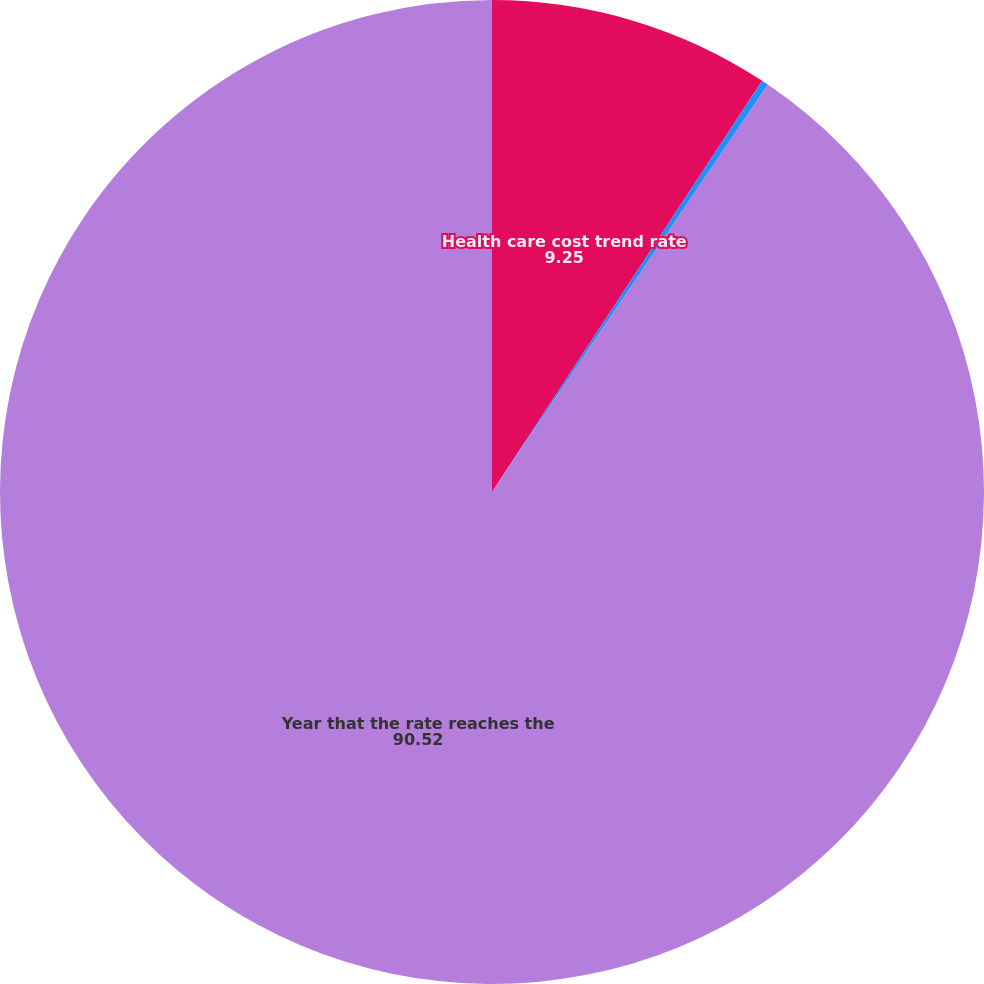Convert chart. <chart><loc_0><loc_0><loc_500><loc_500><pie_chart><fcel>Health care cost trend rate<fcel>Rate that the cost trend rate<fcel>Year that the rate reaches the<nl><fcel>9.25%<fcel>0.22%<fcel>90.52%<nl></chart> 